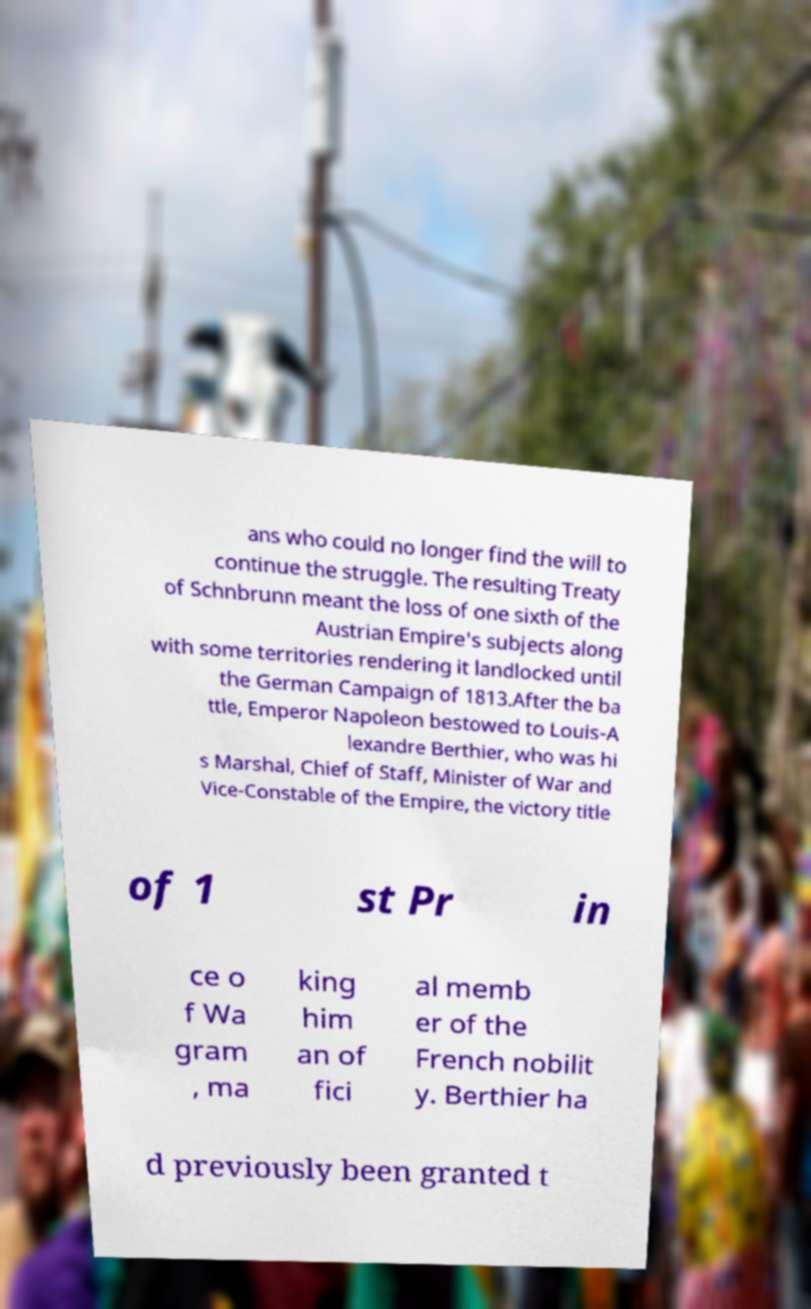I need the written content from this picture converted into text. Can you do that? ans who could no longer find the will to continue the struggle. The resulting Treaty of Schnbrunn meant the loss of one sixth of the Austrian Empire's subjects along with some territories rendering it landlocked until the German Campaign of 1813.After the ba ttle, Emperor Napoleon bestowed to Louis-A lexandre Berthier, who was hi s Marshal, Chief of Staff, Minister of War and Vice-Constable of the Empire, the victory title of 1 st Pr in ce o f Wa gram , ma king him an of fici al memb er of the French nobilit y. Berthier ha d previously been granted t 